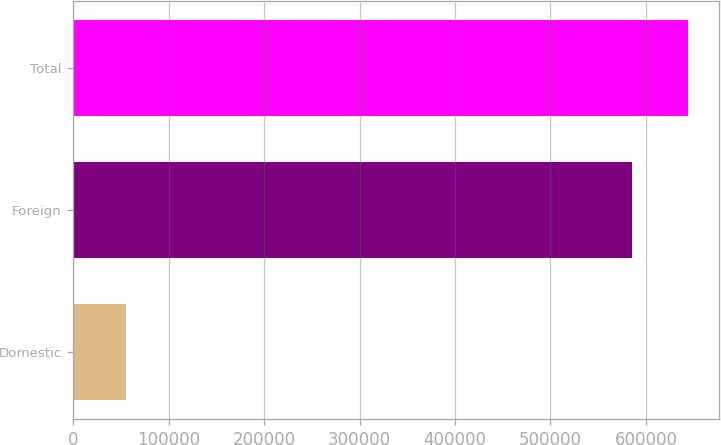<chart> <loc_0><loc_0><loc_500><loc_500><bar_chart><fcel>Domestic<fcel>Foreign<fcel>Total<nl><fcel>55751<fcel>585346<fcel>643881<nl></chart> 